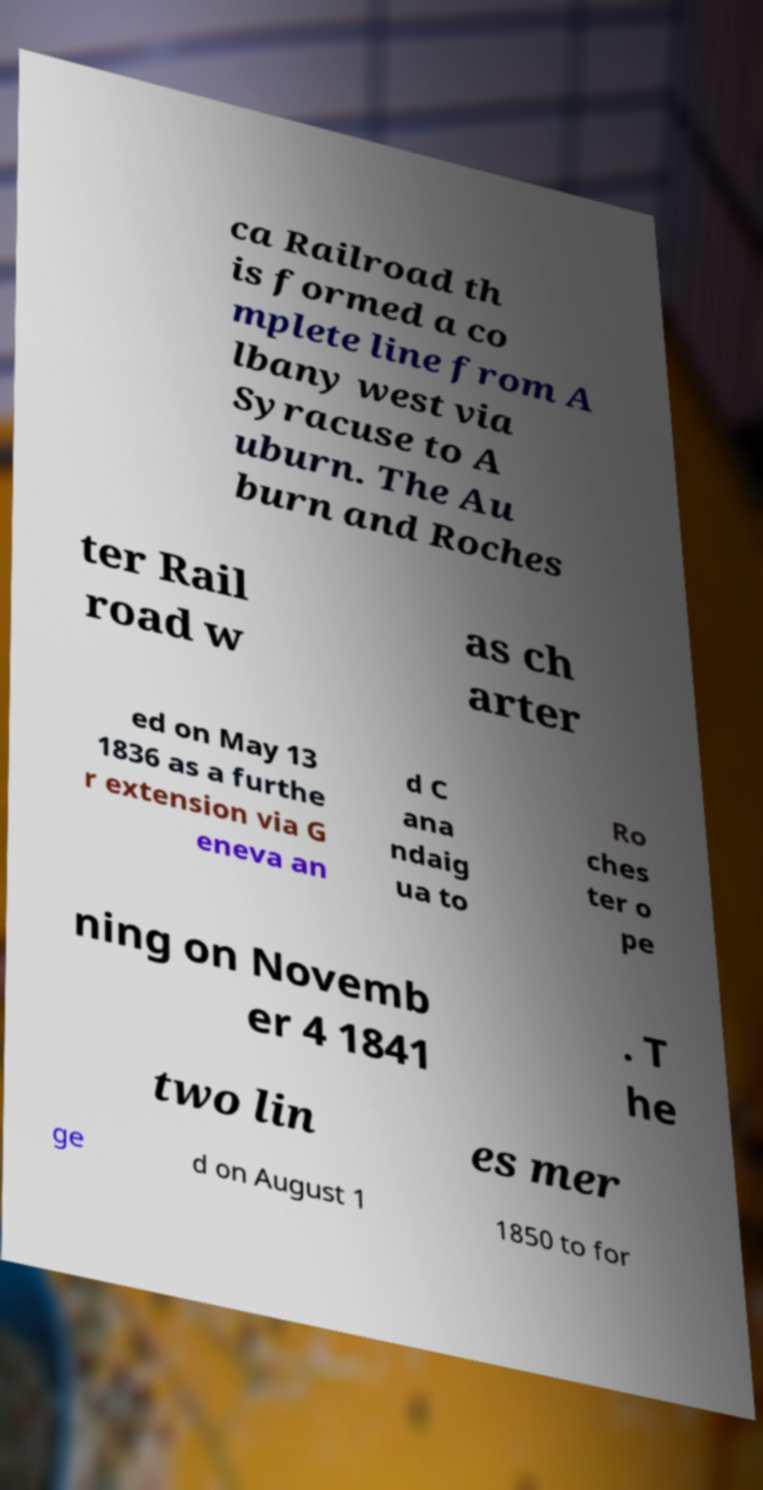Could you extract and type out the text from this image? ca Railroad th is formed a co mplete line from A lbany west via Syracuse to A uburn. The Au burn and Roches ter Rail road w as ch arter ed on May 13 1836 as a furthe r extension via G eneva an d C ana ndaig ua to Ro ches ter o pe ning on Novemb er 4 1841 . T he two lin es mer ge d on August 1 1850 to for 